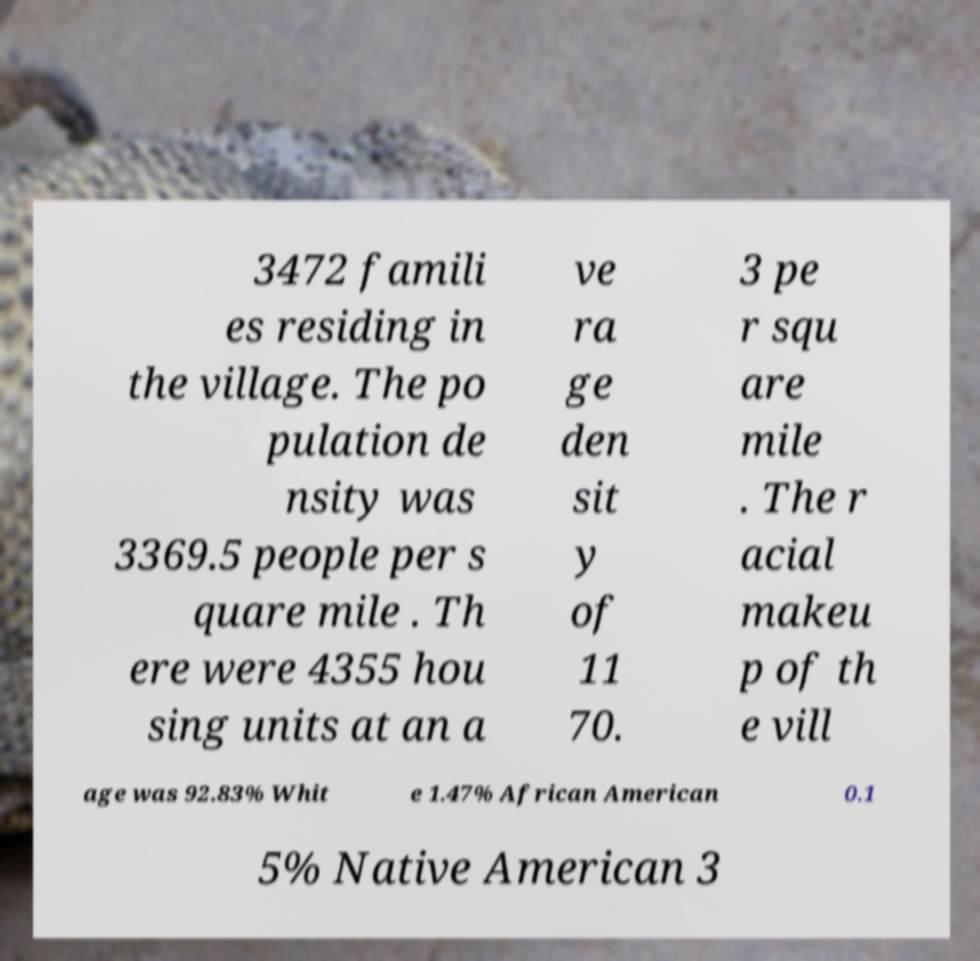Could you extract and type out the text from this image? 3472 famili es residing in the village. The po pulation de nsity was 3369.5 people per s quare mile . Th ere were 4355 hou sing units at an a ve ra ge den sit y of 11 70. 3 pe r squ are mile . The r acial makeu p of th e vill age was 92.83% Whit e 1.47% African American 0.1 5% Native American 3 